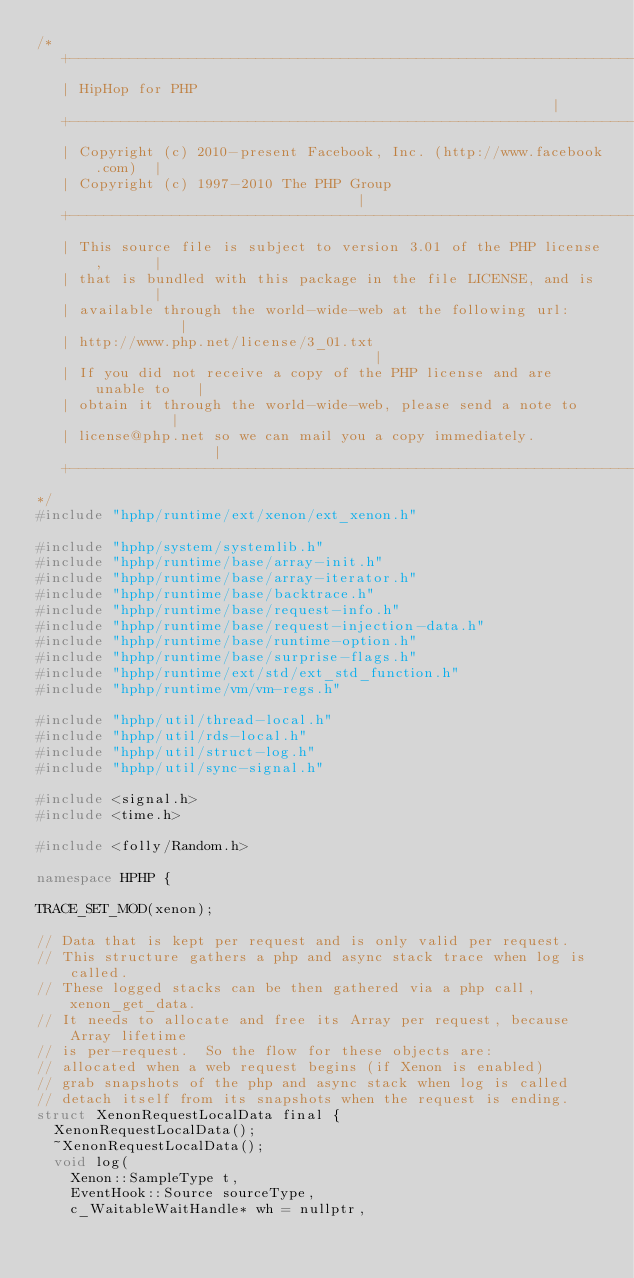Convert code to text. <code><loc_0><loc_0><loc_500><loc_500><_C++_>/*
   +----------------------------------------------------------------------+
   | HipHop for PHP                                                       |
   +----------------------------------------------------------------------+
   | Copyright (c) 2010-present Facebook, Inc. (http://www.facebook.com)  |
   | Copyright (c) 1997-2010 The PHP Group                                |
   +----------------------------------------------------------------------+
   | This source file is subject to version 3.01 of the PHP license,      |
   | that is bundled with this package in the file LICENSE, and is        |
   | available through the world-wide-web at the following url:           |
   | http://www.php.net/license/3_01.txt                                  |
   | If you did not receive a copy of the PHP license and are unable to   |
   | obtain it through the world-wide-web, please send a note to          |
   | license@php.net so we can mail you a copy immediately.               |
   +----------------------------------------------------------------------+
*/
#include "hphp/runtime/ext/xenon/ext_xenon.h"

#include "hphp/system/systemlib.h"
#include "hphp/runtime/base/array-init.h"
#include "hphp/runtime/base/array-iterator.h"
#include "hphp/runtime/base/backtrace.h"
#include "hphp/runtime/base/request-info.h"
#include "hphp/runtime/base/request-injection-data.h"
#include "hphp/runtime/base/runtime-option.h"
#include "hphp/runtime/base/surprise-flags.h"
#include "hphp/runtime/ext/std/ext_std_function.h"
#include "hphp/runtime/vm/vm-regs.h"

#include "hphp/util/thread-local.h"
#include "hphp/util/rds-local.h"
#include "hphp/util/struct-log.h"
#include "hphp/util/sync-signal.h"

#include <signal.h>
#include <time.h>

#include <folly/Random.h>

namespace HPHP {

TRACE_SET_MOD(xenon);

// Data that is kept per request and is only valid per request.
// This structure gathers a php and async stack trace when log is called.
// These logged stacks can be then gathered via a php call, xenon_get_data.
// It needs to allocate and free its Array per request, because Array lifetime
// is per-request.  So the flow for these objects are:
// allocated when a web request begins (if Xenon is enabled)
// grab snapshots of the php and async stack when log is called
// detach itself from its snapshots when the request is ending.
struct XenonRequestLocalData final {
  XenonRequestLocalData();
  ~XenonRequestLocalData();
  void log(
    Xenon::SampleType t,
    EventHook::Source sourceType,
    c_WaitableWaitHandle* wh = nullptr,</code> 